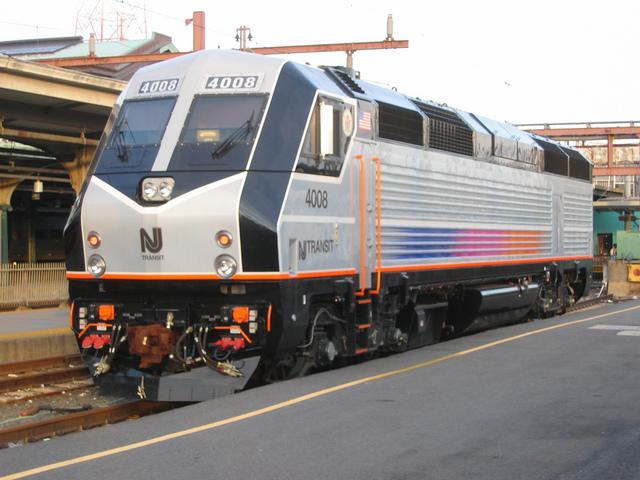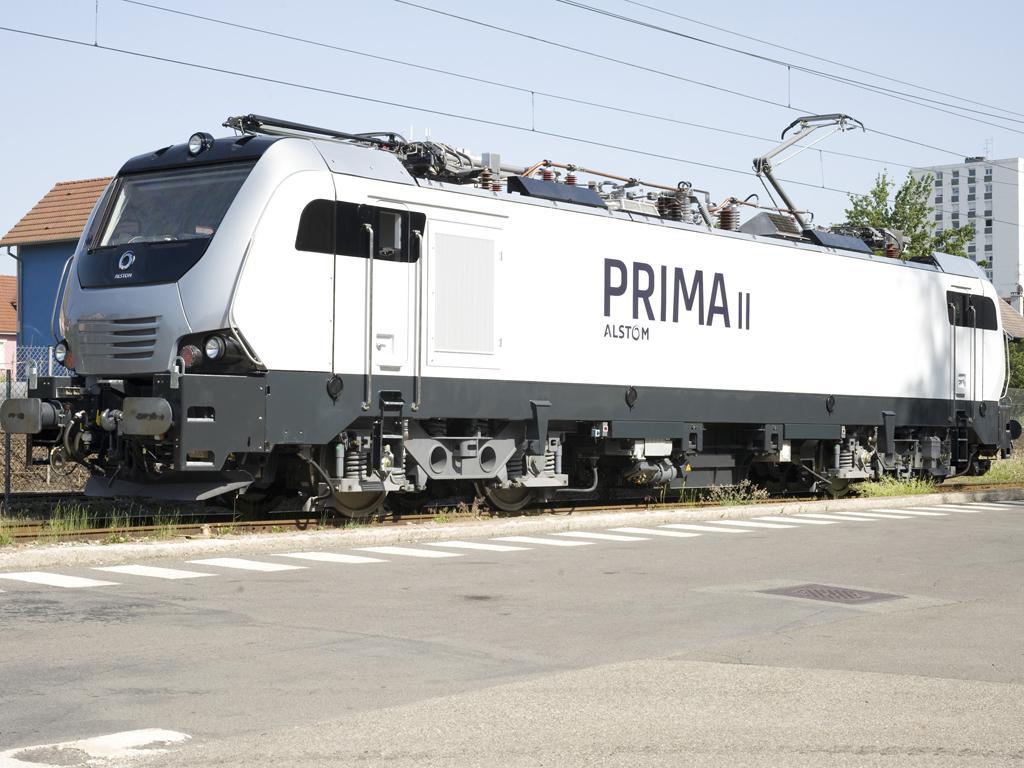The first image is the image on the left, the second image is the image on the right. Given the left and right images, does the statement "Both trains are facing left." hold true? Answer yes or no. Yes. The first image is the image on the left, the second image is the image on the right. Considering the images on both sides, is "One of the trains features the colors red, white, and blue with a blue stripe running the entire length of the car." valid? Answer yes or no. No. 